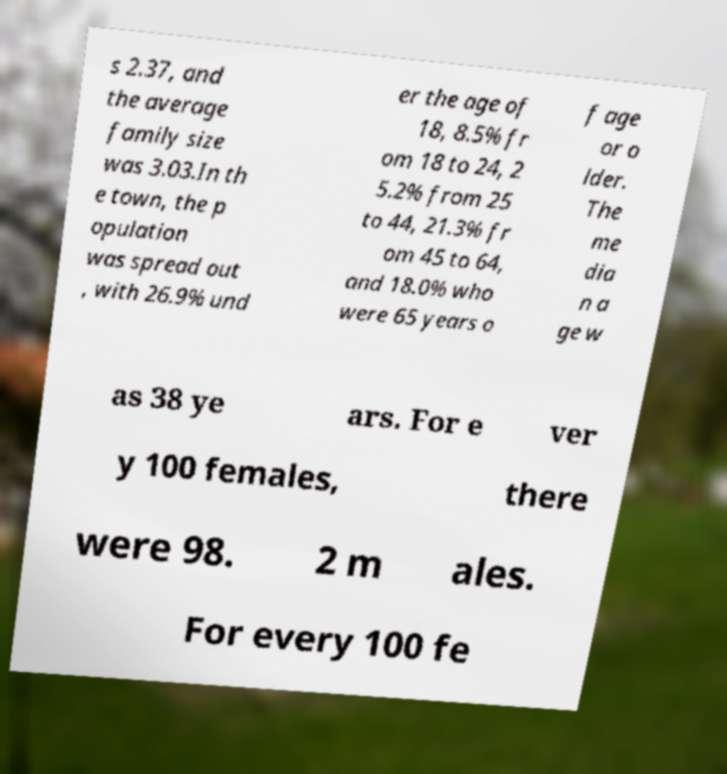Please identify and transcribe the text found in this image. s 2.37, and the average family size was 3.03.In th e town, the p opulation was spread out , with 26.9% und er the age of 18, 8.5% fr om 18 to 24, 2 5.2% from 25 to 44, 21.3% fr om 45 to 64, and 18.0% who were 65 years o f age or o lder. The me dia n a ge w as 38 ye ars. For e ver y 100 females, there were 98. 2 m ales. For every 100 fe 